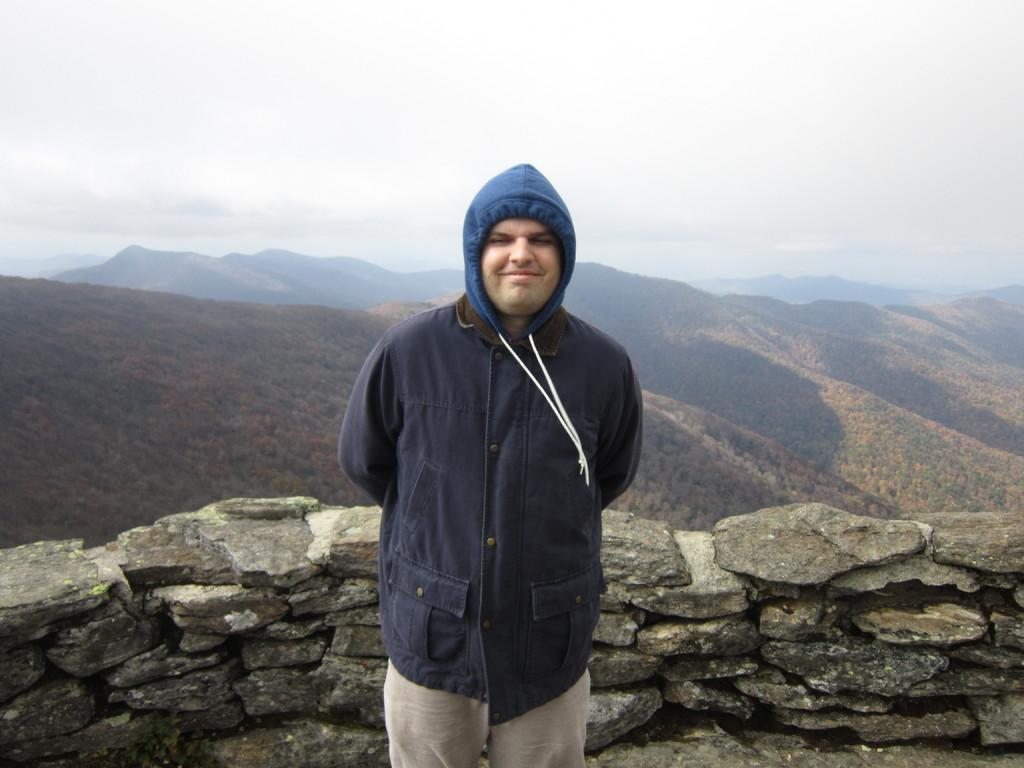Who is present in the image? There is a man in the image. What is the man doing in the image? The man is standing. What type of structure can be seen in the image? There is a stone wall in the image. What natural feature is visible in the image? There are mountains visible in the image. What brand of toothpaste is the man using in the image? There is no toothpaste present in the image, and the man's actions do not involve using toothpaste. Is there a garden visible in the image? No, there is no garden visible in the image; only a stone wall and mountains are present. 